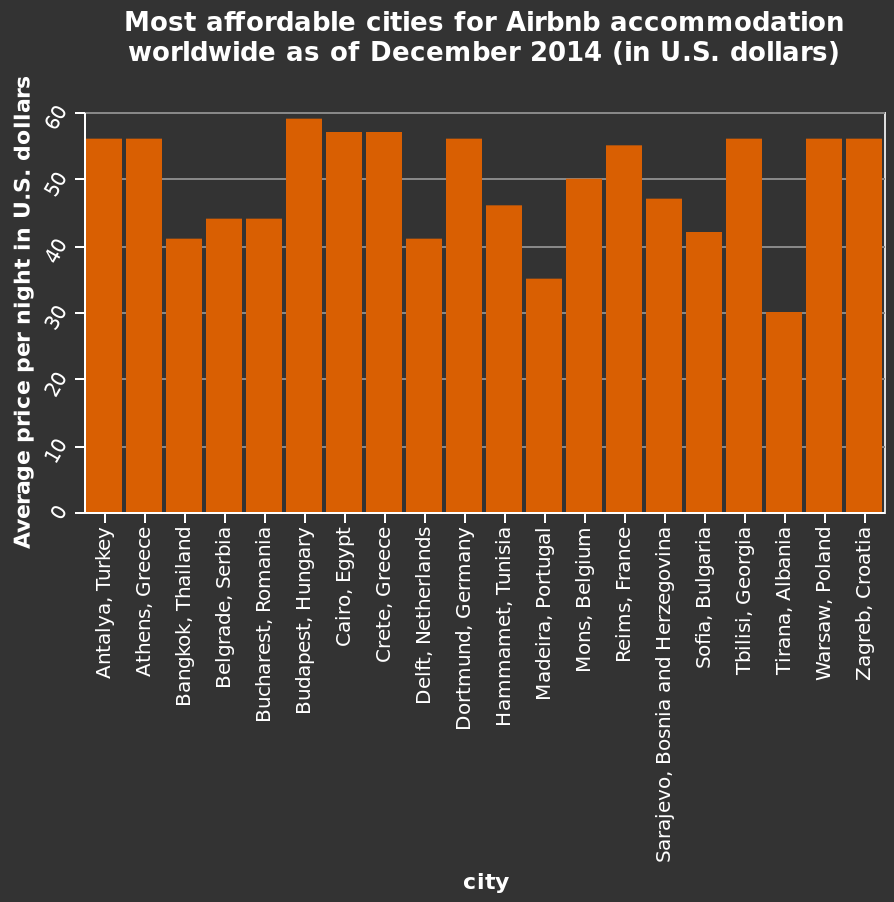<image>
What is the time frame for the data presented in the bar diagram? The data presented in the bar diagram is as of December 2014. How much did Air BnB accommodation cost in Tirana in 2014? Air BnB accommodation in Tirana cost 30 dollars a night in 2014. 